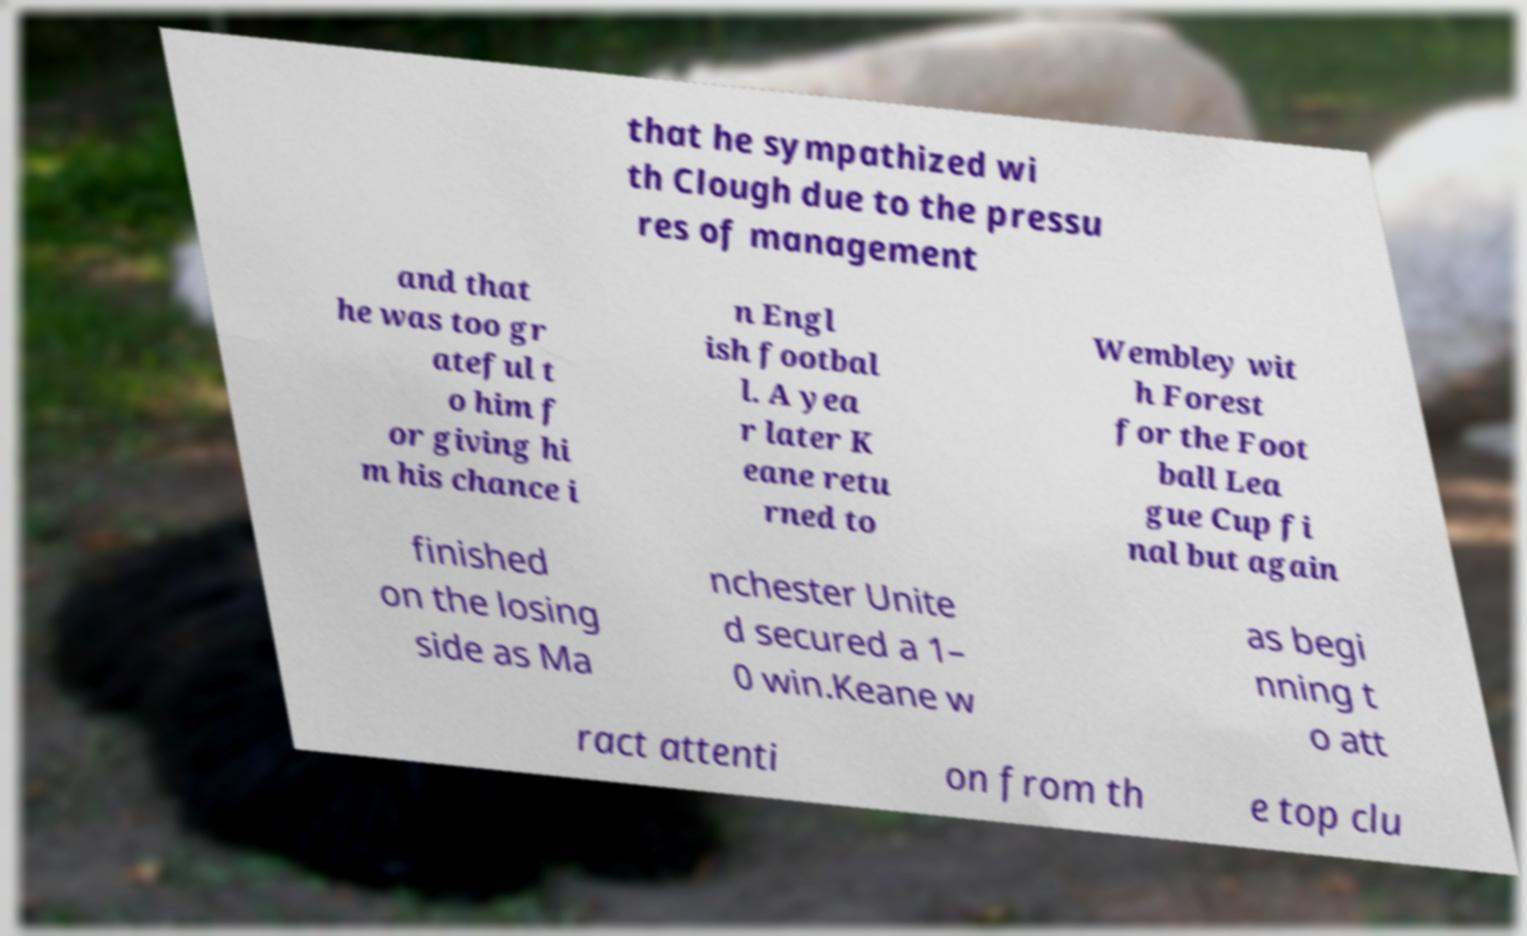Please identify and transcribe the text found in this image. that he sympathized wi th Clough due to the pressu res of management and that he was too gr ateful t o him f or giving hi m his chance i n Engl ish footbal l. A yea r later K eane retu rned to Wembley wit h Forest for the Foot ball Lea gue Cup fi nal but again finished on the losing side as Ma nchester Unite d secured a 1– 0 win.Keane w as begi nning t o att ract attenti on from th e top clu 